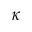<formula> <loc_0><loc_0><loc_500><loc_500>\kappa</formula> 